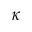<formula> <loc_0><loc_0><loc_500><loc_500>\kappa</formula> 